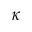<formula> <loc_0><loc_0><loc_500><loc_500>\kappa</formula> 